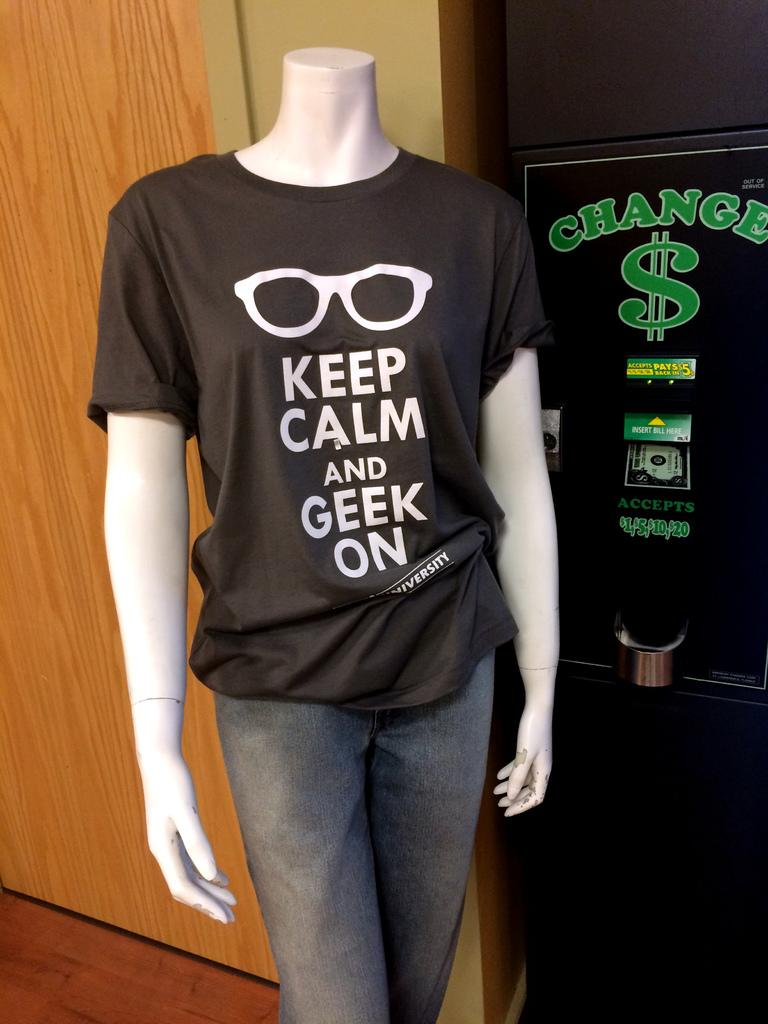<image>
Write a terse but informative summary of the picture. A mannequin standing in front of a kiosk that provides change for dollar bills. 